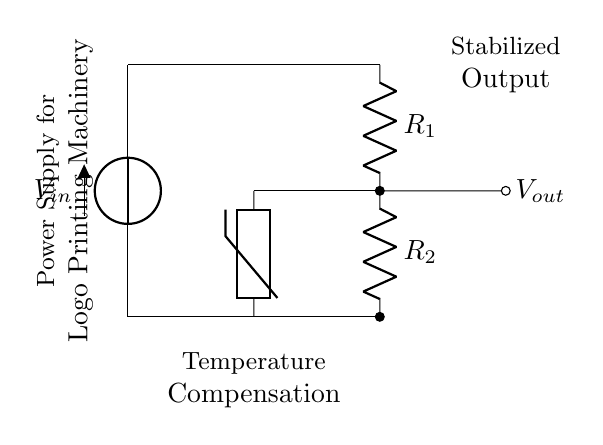What is the input voltage denoted as in the circuit? The input voltage is labeled as V_in in the circuit. This indicates the voltage supplied to the voltage divider.
Answer: V_in What are the resistors present in the circuit? The resistors in the circuit are labeled as R_1 and R_2. These components are part of the voltage divider configuration, which is responsible for dividing the input voltage.
Answer: R_1, R_2 What is the purpose of the thermistor in this circuit? The thermistor in the circuit serves the purpose of temperature compensation, which helps maintain output stability despite temperature variations. This is important for ensuring the consistent operation of the logo printing machinery.
Answer: Temperature compensation How is the output voltage labeled in the circuit? The output voltage is indicated with the label V_out in the circuit diagram, which signifies the voltage taken from the voltage divider's output point.
Answer: V_out What type of circuit is this configuration? This configuration is specifically a voltage divider, which is used for reducing the voltage to a desired level. It uses resistors and is commonly employed in power supply applications.
Answer: Voltage divider How does temperature affect the output voltage in this setup? Temperature affects the output voltage because the thermistor changes its resistance with temperature fluctuations. This change is used to adjust the voltage divider's output to provide a stable voltage to the logo printing machinery regardless of temperature changes.
Answer: Output stability What is the final destination of the stabilized output in the circuit? The stabilized output is directed towards the power supply for logo printing machinery. This shows that the voltage divider's purpose is to deliver a stable voltage for equipment operation.
Answer: Power supply for logo printing machinery 